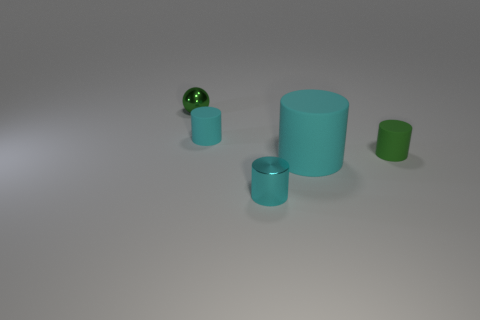Subtract all gray cubes. How many cyan cylinders are left? 3 Add 2 tiny green metal things. How many objects exist? 7 Subtract all balls. How many objects are left? 4 Add 1 shiny blocks. How many shiny blocks exist? 1 Subtract 0 red spheres. How many objects are left? 5 Subtract all spheres. Subtract all matte cylinders. How many objects are left? 1 Add 3 large cyan cylinders. How many large cyan cylinders are left? 4 